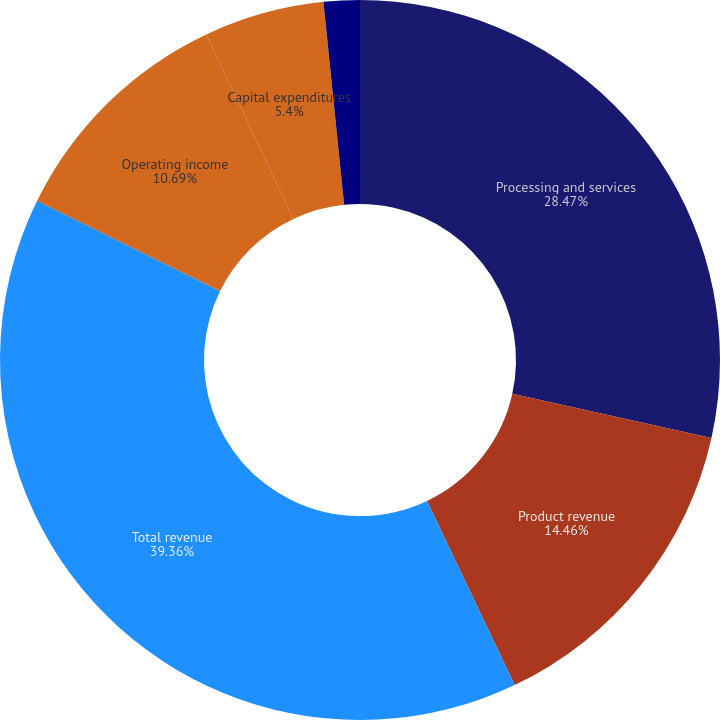Convert chart to OTSL. <chart><loc_0><loc_0><loc_500><loc_500><pie_chart><fcel>Processing and services<fcel>Product revenue<fcel>Total revenue<fcel>Operating income<fcel>Capital expenditures<fcel>Depreciation and amortization<nl><fcel>28.47%<fcel>14.46%<fcel>39.35%<fcel>10.69%<fcel>5.4%<fcel>1.62%<nl></chart> 